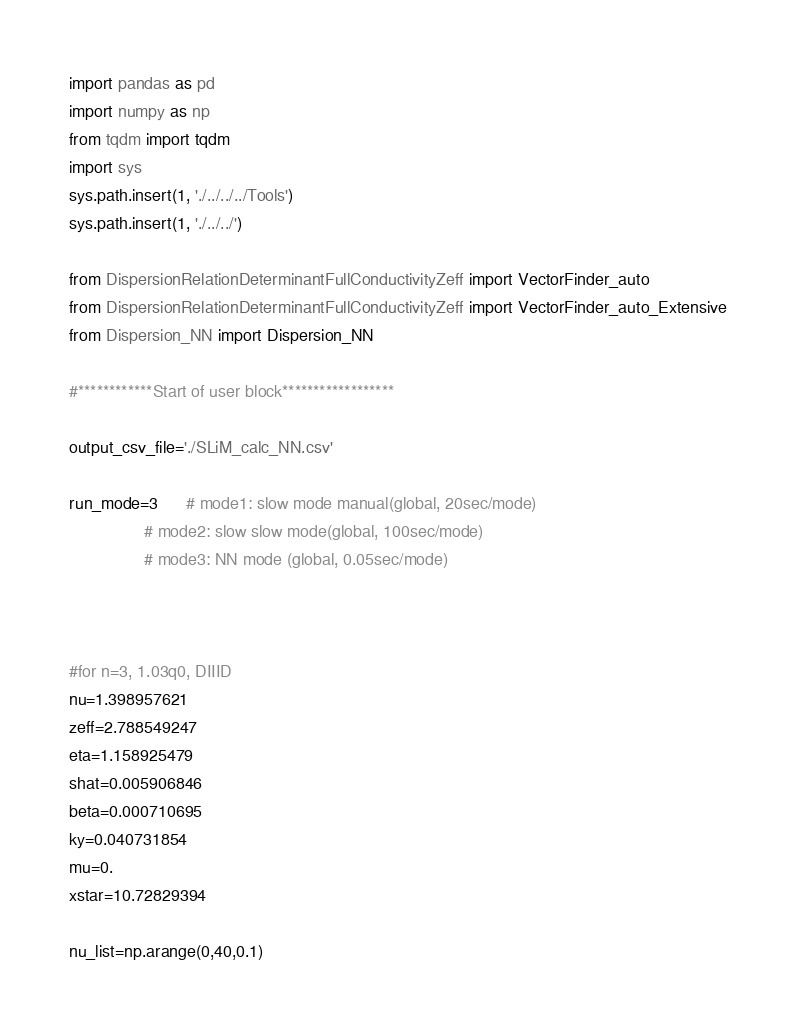Convert code to text. <code><loc_0><loc_0><loc_500><loc_500><_Python_>import pandas as pd
import numpy as np
from tqdm import tqdm
import sys
sys.path.insert(1, './../../../Tools')
sys.path.insert(1, './../../')

from DispersionRelationDeterminantFullConductivityZeff import VectorFinder_auto
from DispersionRelationDeterminantFullConductivityZeff import VectorFinder_auto_Extensive
from Dispersion_NN import Dispersion_NN

#************Start of user block******************

output_csv_file='./SLiM_calc_NN.csv'

run_mode=3      # mode1: slow mode manual(global, 20sec/mode)
                # mode2: slow slow mode(global, 100sec/mode)
                # mode3: NN mode (global, 0.05sec/mode)


     
#for n=3, 1.03q0, DIIID 
nu=1.398957621
zeff=2.788549247
eta=1.158925479
shat=0.005906846
beta=0.000710695
ky=0.040731854
mu=0.
xstar=10.72829394

nu_list=np.arange(0,40,0.1)
</code> 